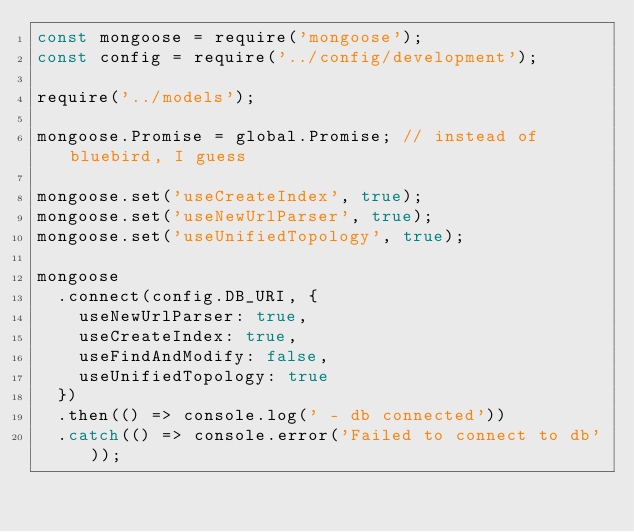Convert code to text. <code><loc_0><loc_0><loc_500><loc_500><_JavaScript_>const mongoose = require('mongoose');
const config = require('../config/development');

require('../models');

mongoose.Promise = global.Promise; // instead of bluebird, I guess

mongoose.set('useCreateIndex', true);
mongoose.set('useNewUrlParser', true);
mongoose.set('useUnifiedTopology', true);

mongoose
  .connect(config.DB_URI, {
    useNewUrlParser: true,
    useCreateIndex: true,
    useFindAndModify: false,
    useUnifiedTopology: true
  })
  .then(() => console.log(' - db connected'))
  .catch(() => console.error('Failed to connect to db'));
</code> 